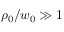<formula> <loc_0><loc_0><loc_500><loc_500>\rho _ { 0 } / w _ { 0 } \gg 1</formula> 